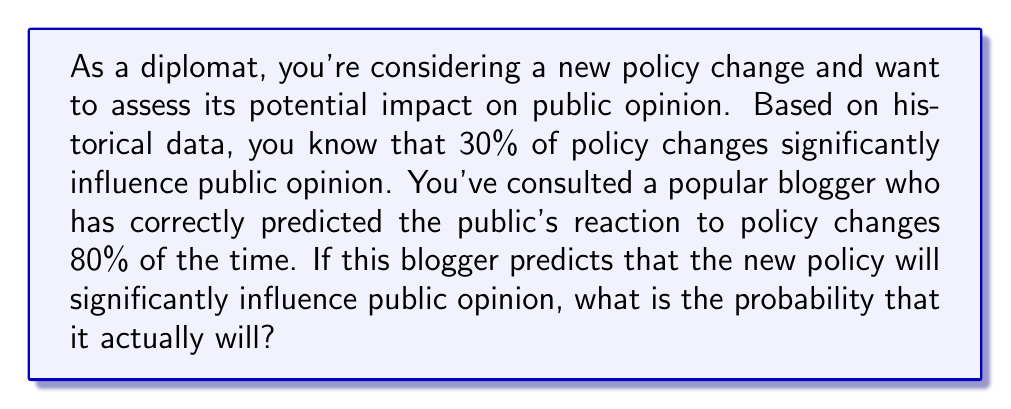Solve this math problem. Let's approach this problem using Bayesian inference:

1) Define our events:
   A: The policy change significantly influences public opinion
   B: The blogger predicts the policy will significantly influence public opinion

2) Given information:
   $P(A) = 0.30$ (prior probability)
   $P(B|A) = 0.80$ (probability of correct prediction given significant influence)
   $P(B|\neg A) = 0.20$ (probability of incorrect prediction given no significant influence)

3) We want to find $P(A|B)$ using Bayes' theorem:

   $$P(A|B) = \frac{P(B|A) \cdot P(A)}{P(B)}$$

4) Calculate $P(B)$ using the law of total probability:
   
   $$P(B) = P(B|A) \cdot P(A) + P(B|\neg A) \cdot P(\neg A)$$
   $$P(B) = 0.80 \cdot 0.30 + 0.20 \cdot 0.70 = 0.24 + 0.14 = 0.38$$

5) Now we can apply Bayes' theorem:

   $$P(A|B) = \frac{0.80 \cdot 0.30}{0.38} = \frac{0.24}{0.38} \approx 0.6316$$

6) Convert to a percentage: 0.6316 * 100 ≈ 63.16%

Therefore, if the blogger predicts that the new policy will significantly influence public opinion, there is approximately a 63.16% chance that it actually will.
Answer: 63.16% 